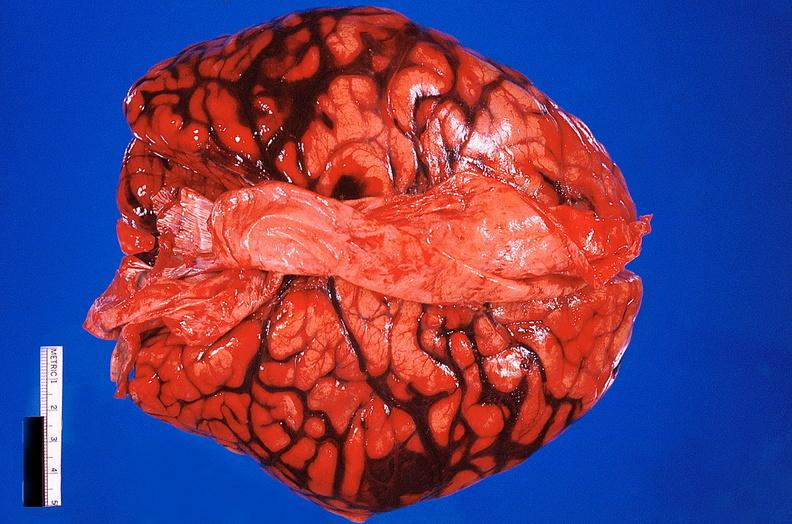what is present?
Answer the question using a single word or phrase. Nervous 